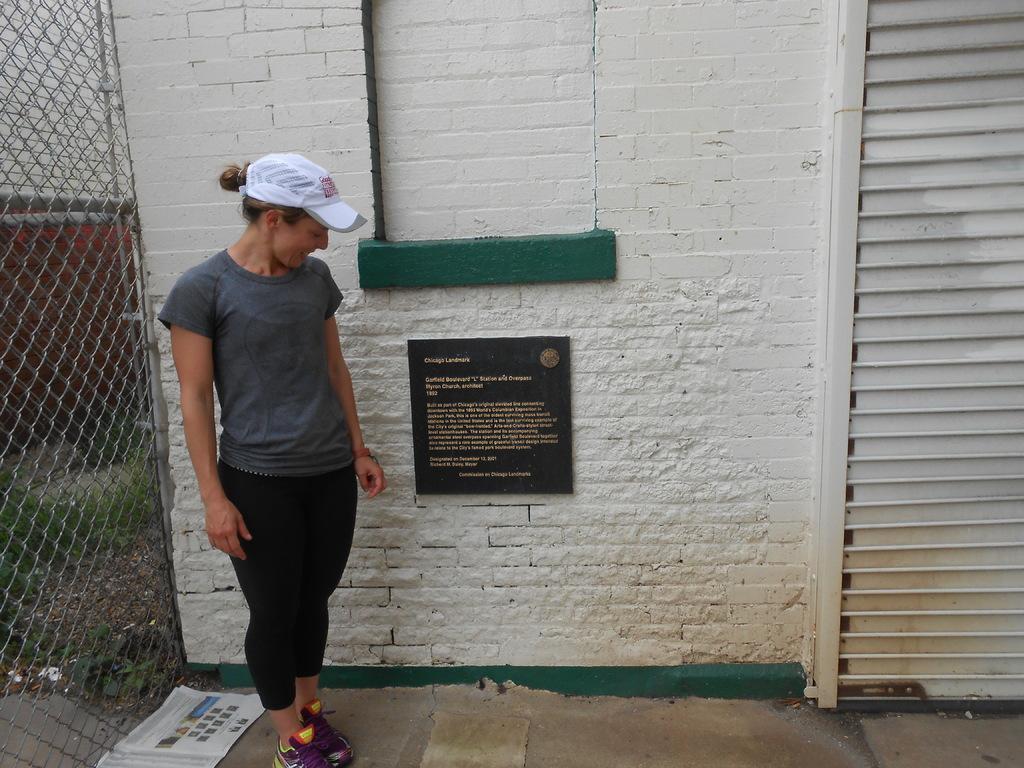Please provide a concise description of this image. In this image I can see a woman wearing a gray color t-shirt and white color cap standing on the floor, in the middle I can see the wall and a notice board attached to the wall. And on the left side I can see the fence. 